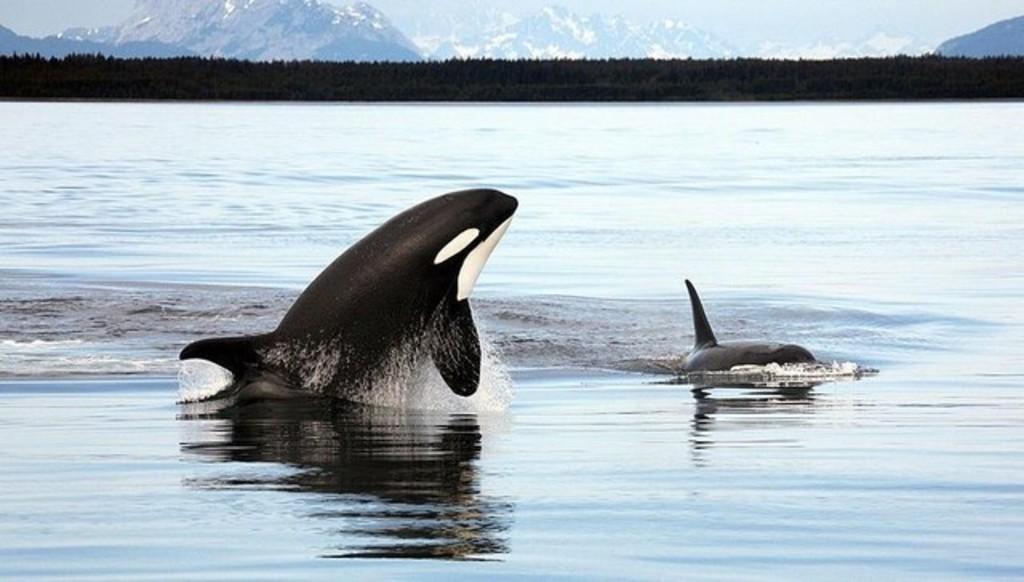Can you describe this image briefly? This picture shows couple of dolphins in the water and we see trees and mountains. 